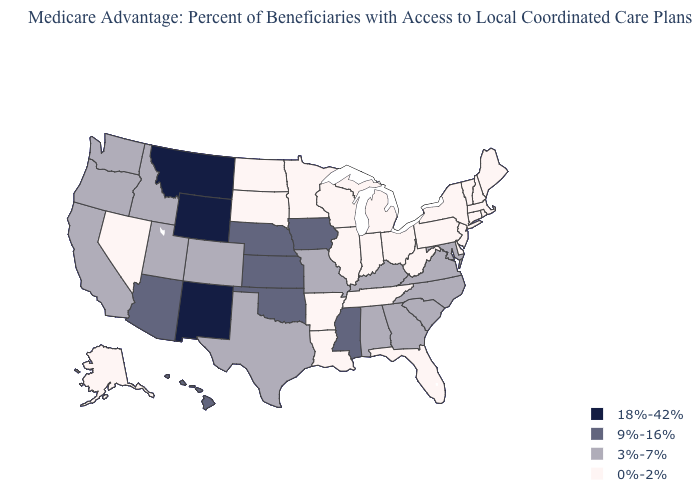Does Maryland have the same value as Ohio?
Give a very brief answer. No. Name the states that have a value in the range 3%-7%?
Answer briefly. Alabama, California, Colorado, Georgia, Idaho, Kentucky, Maryland, Missouri, North Carolina, Oregon, South Carolina, Texas, Utah, Virginia, Washington. What is the value of Missouri?
Answer briefly. 3%-7%. Which states have the highest value in the USA?
Be succinct. Montana, New Mexico, Wyoming. What is the lowest value in the USA?
Short answer required. 0%-2%. Which states have the highest value in the USA?
Quick response, please. Montana, New Mexico, Wyoming. Among the states that border New Mexico , which have the lowest value?
Quick response, please. Colorado, Texas, Utah. What is the value of New Mexico?
Quick response, please. 18%-42%. What is the value of Alabama?
Give a very brief answer. 3%-7%. Does the map have missing data?
Give a very brief answer. No. Does the map have missing data?
Concise answer only. No. What is the value of Wyoming?
Short answer required. 18%-42%. What is the highest value in the MidWest ?
Concise answer only. 9%-16%. What is the highest value in the USA?
Concise answer only. 18%-42%. What is the value of Oklahoma?
Short answer required. 9%-16%. 